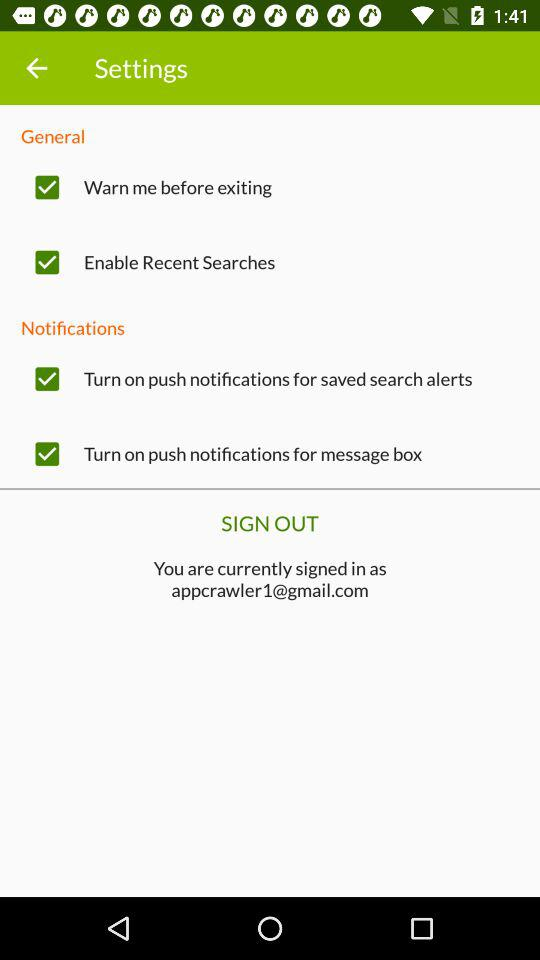What is the status of "Warn me before exiting"? The status is "on". 